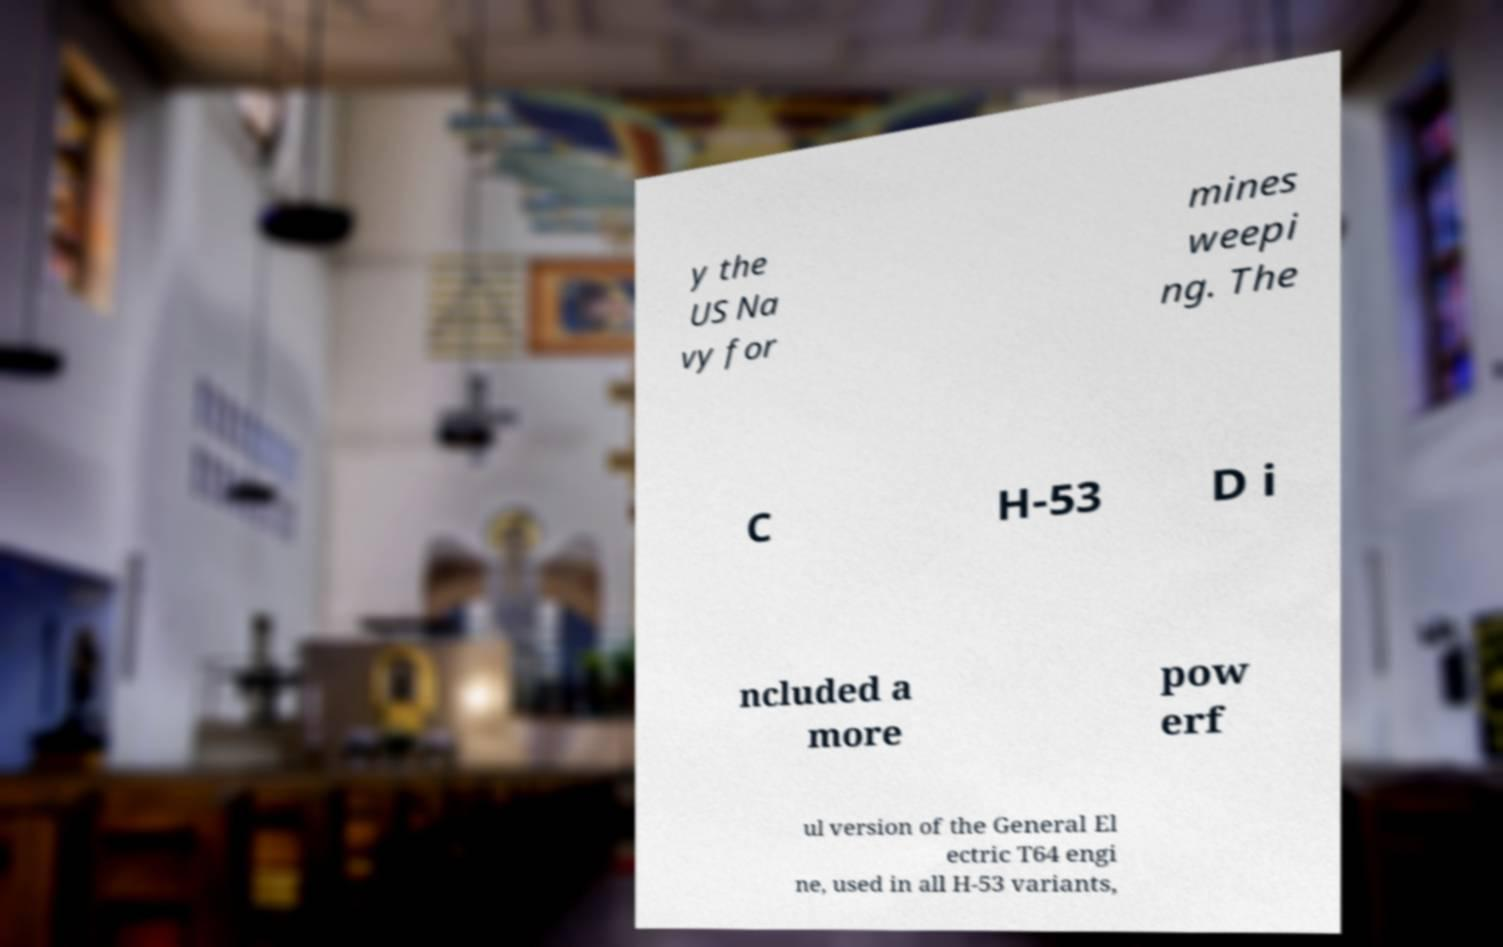Could you extract and type out the text from this image? y the US Na vy for mines weepi ng. The C H-53 D i ncluded a more pow erf ul version of the General El ectric T64 engi ne, used in all H-53 variants, 